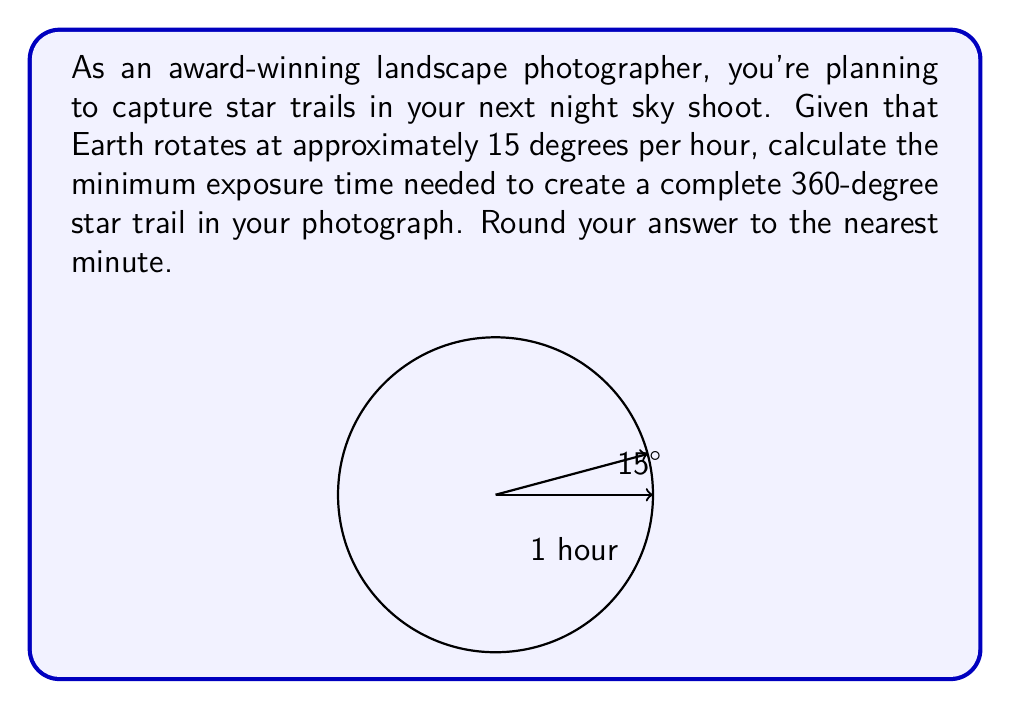Could you help me with this problem? Let's approach this step-by-step:

1) We know that Earth rotates at 15 degrees per hour. We can express this as a rate:

   $$\text{Rotation rate} = \frac{15\text{ degrees}}{\text{1 hour}}$$

2) We want to find the time needed for a complete 360-degree rotation. We can set up the following equation:

   $$\frac{15\text{ degrees}}{\text{1 hour}} = \frac{360\text{ degrees}}{x\text{ hours}}$$

3) Cross-multiplying, we get:

   $$15x = 360$$

4) Solving for $x$:

   $$x = \frac{360}{15} = 24\text{ hours}$$

5) Converting 24 hours to minutes:

   $$24\text{ hours} \times 60\text{ minutes/hour} = 1440\text{ minutes}$$

Therefore, it would take 1440 minutes (or 24 hours) for a complete 360-degree star trail.
Answer: 1440 minutes 